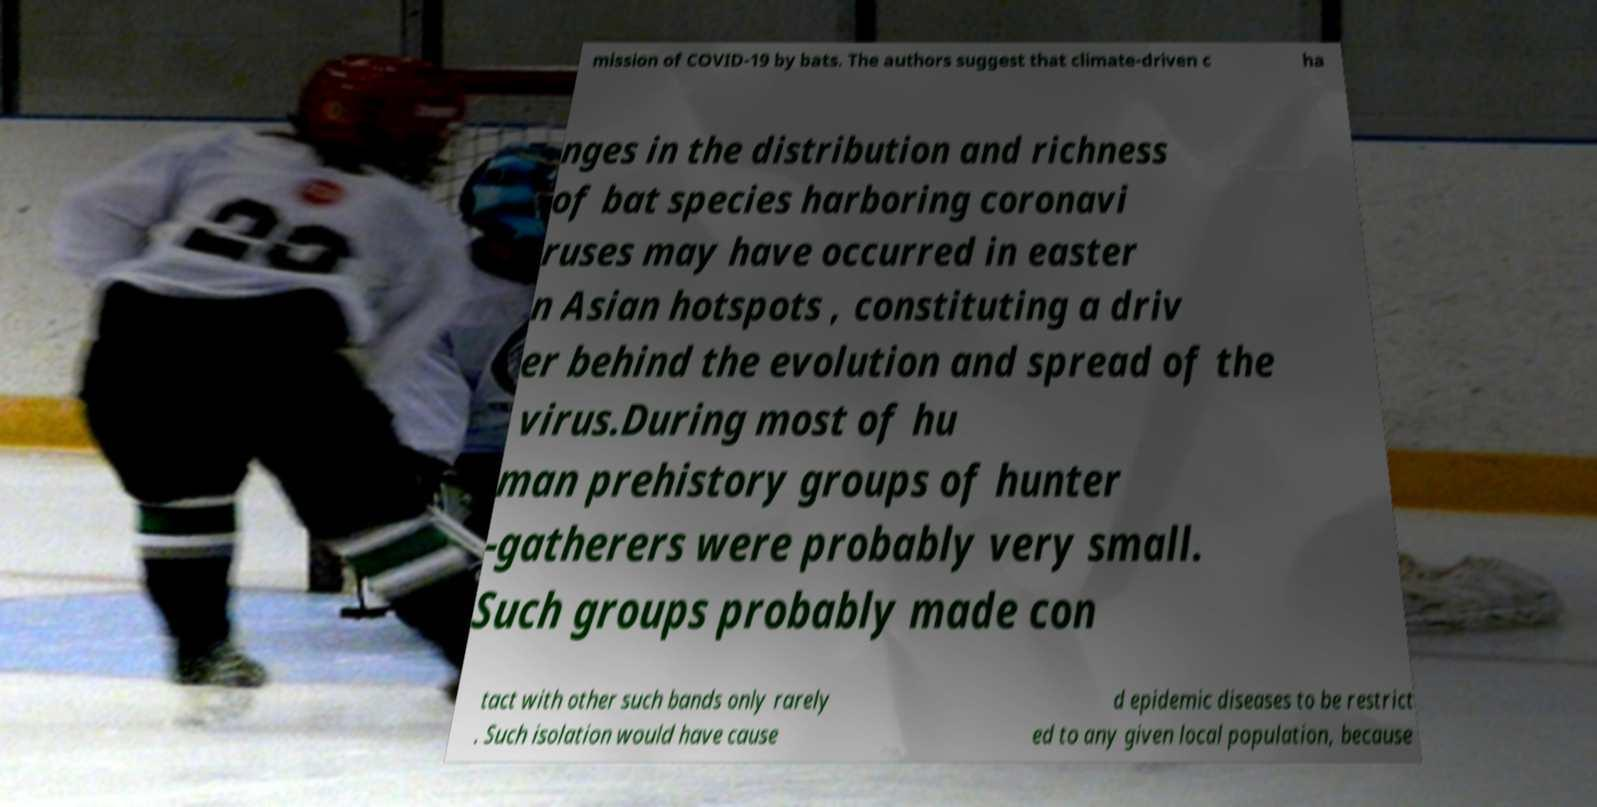Can you accurately transcribe the text from the provided image for me? mission of COVID-19 by bats. The authors suggest that climate-driven c ha nges in the distribution and richness of bat species harboring coronavi ruses may have occurred in easter n Asian hotspots , constituting a driv er behind the evolution and spread of the virus.During most of hu man prehistory groups of hunter -gatherers were probably very small. Such groups probably made con tact with other such bands only rarely . Such isolation would have cause d epidemic diseases to be restrict ed to any given local population, because 